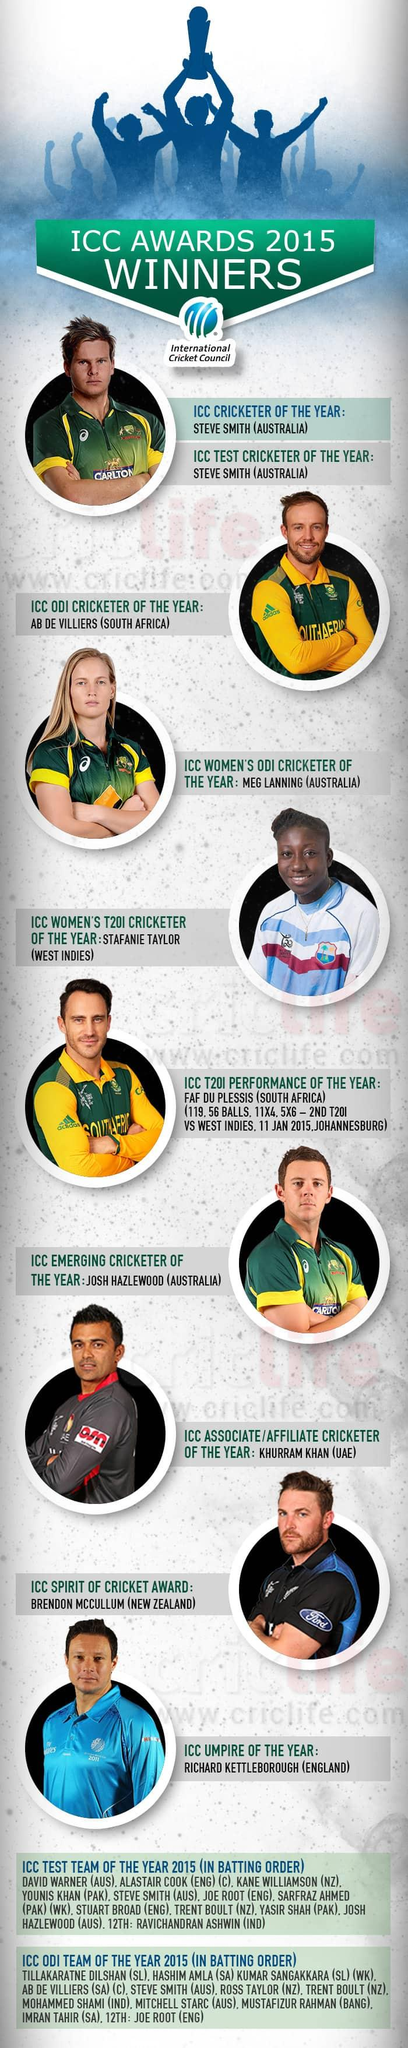Indicate a few pertinent items in this graphic. Australia has won the highest number of ICC awards. In 2015, the women's cricket players Meg Lanning and Stafanie Taylor were awarded the ICC accolades for their exceptional performances. 